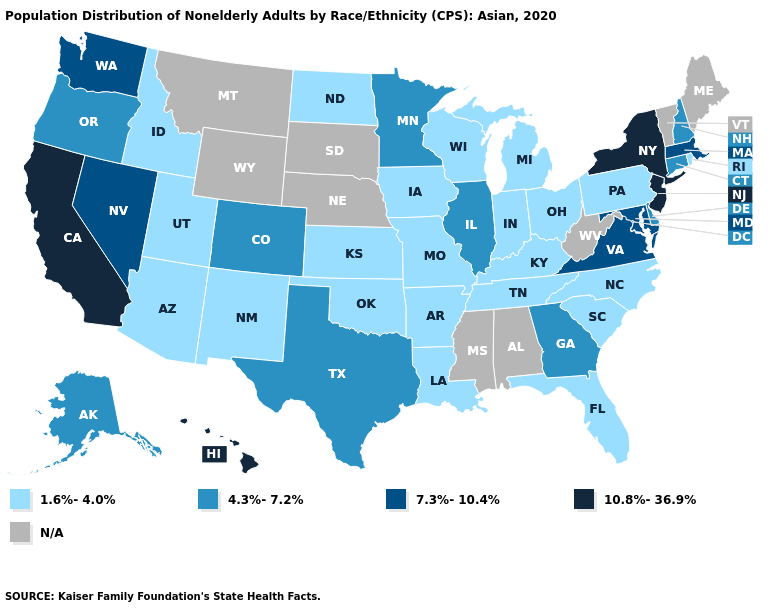What is the value of South Carolina?
Write a very short answer. 1.6%-4.0%. Name the states that have a value in the range 10.8%-36.9%?
Quick response, please. California, Hawaii, New Jersey, New York. What is the lowest value in the West?
Concise answer only. 1.6%-4.0%. What is the value of Oklahoma?
Quick response, please. 1.6%-4.0%. What is the value of Hawaii?
Quick response, please. 10.8%-36.9%. Among the states that border Oklahoma , does Texas have the lowest value?
Concise answer only. No. What is the value of Kentucky?
Answer briefly. 1.6%-4.0%. Is the legend a continuous bar?
Give a very brief answer. No. Is the legend a continuous bar?
Short answer required. No. What is the value of Nevada?
Answer briefly. 7.3%-10.4%. Among the states that border Kentucky , which have the highest value?
Give a very brief answer. Virginia. Does Idaho have the lowest value in the West?
Concise answer only. Yes. 